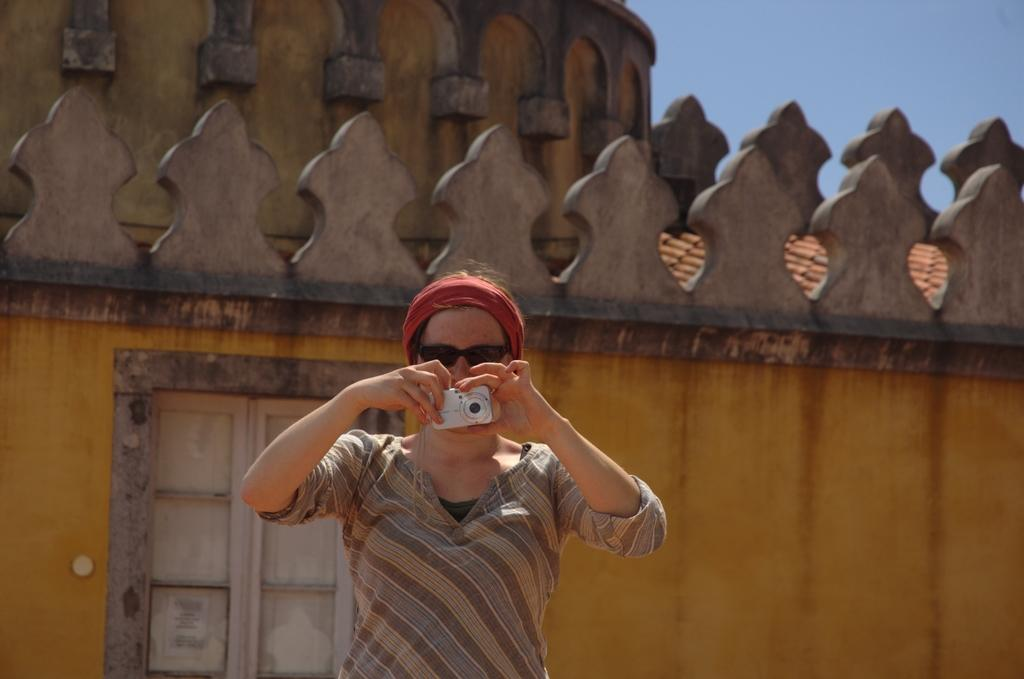Who is the main subject in the image? There is a woman in the image. What is the woman holding in her hands? The woman is holding a camera in her hands. What can be seen in the background of the image? There is a building behind the woman. What type of acoustics can be heard in the image? There is no information about any sounds or acoustics in the image, so it cannot be determined. 